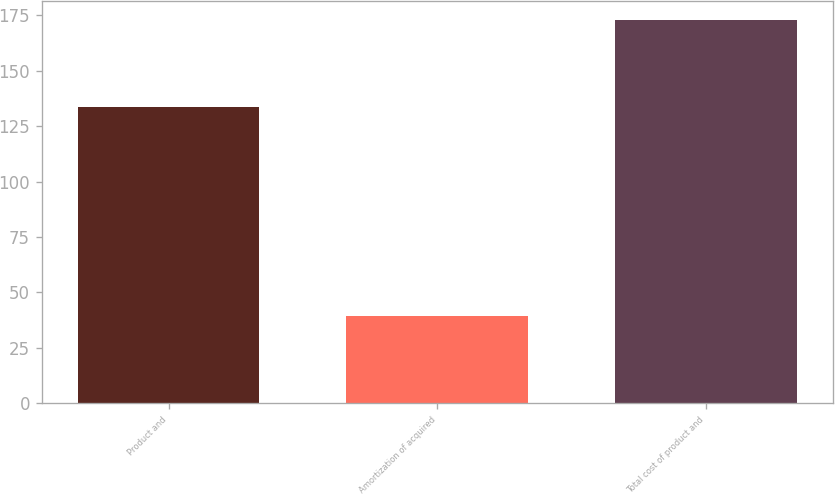Convert chart to OTSL. <chart><loc_0><loc_0><loc_500><loc_500><bar_chart><fcel>Product and<fcel>Amortization of acquired<fcel>Total cost of product and<nl><fcel>133.8<fcel>39.2<fcel>173<nl></chart> 